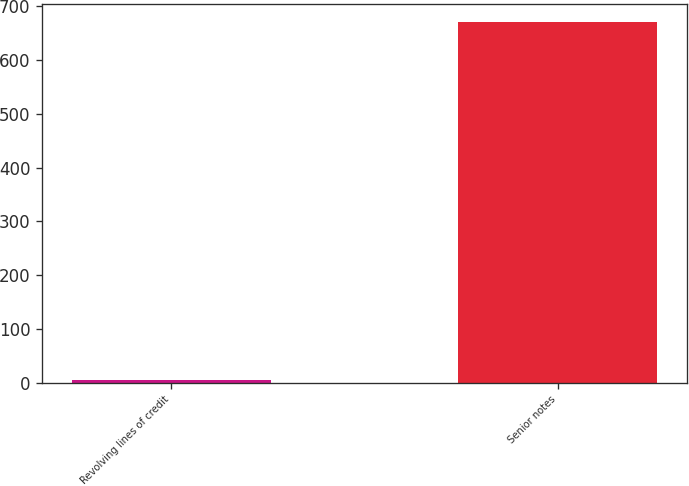Convert chart to OTSL. <chart><loc_0><loc_0><loc_500><loc_500><bar_chart><fcel>Revolving lines of credit<fcel>Senior notes<nl><fcel>5<fcel>670.6<nl></chart> 